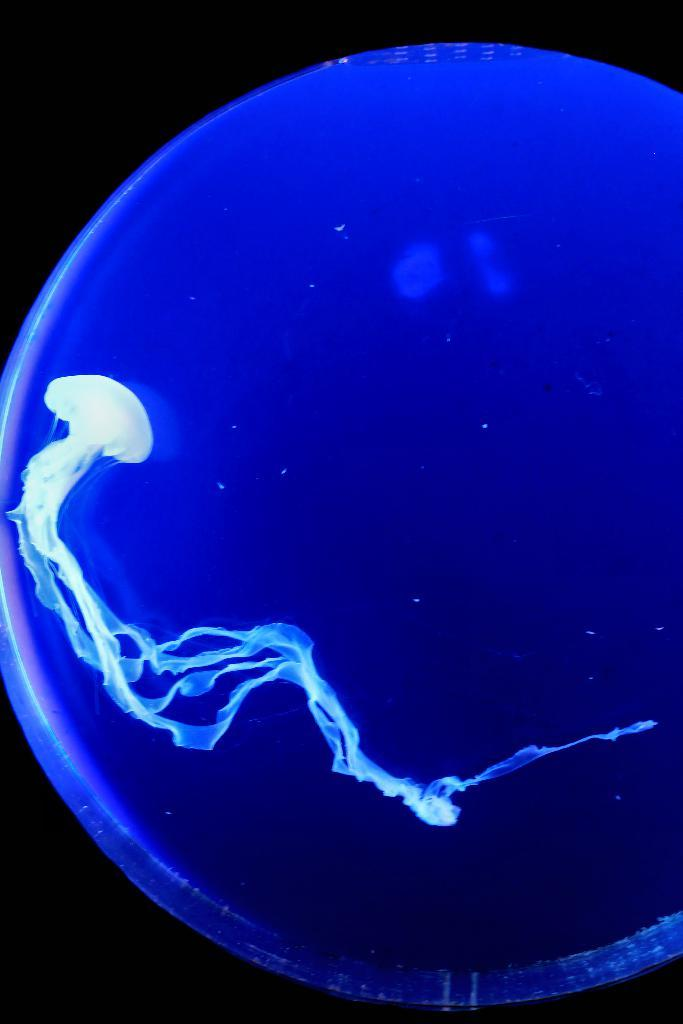What type of animals are present in the image? There are marine invertebrates in the image. What type of cake is being served at the marine invertebrate's birthday party in the image? There is no cake or birthday party present in the image; it features marine invertebrates. How does the marine invertebrate breathe underwater in the image? The image does not show the marine invertebrates breathing, but most marine invertebrates have specialized respiratory systems for underwater breathing. 